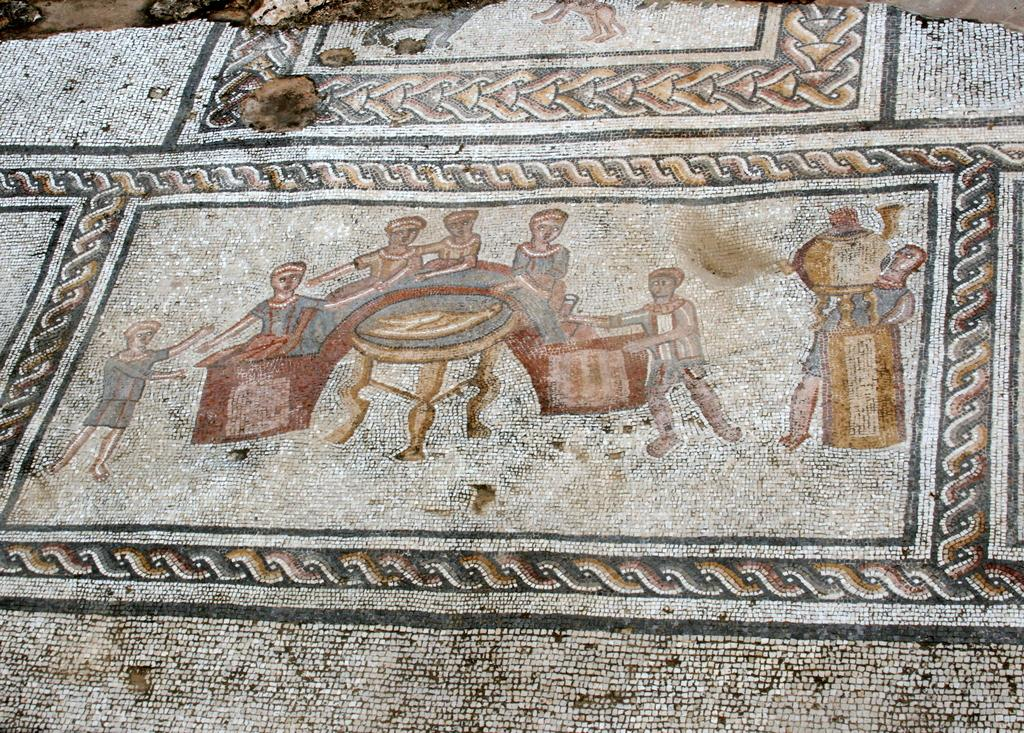What is the main subject in the center of the image? There is a cloth in the center of the image. What is depicted on the cloth? There are paintings on the cloth. What are the people in the paintings doing? The paintings depict people standing and holding objects. What type of head can be seen in the image? There is no head present in the image; the paintings depict people standing and holding objects, but their heads are not visible. 